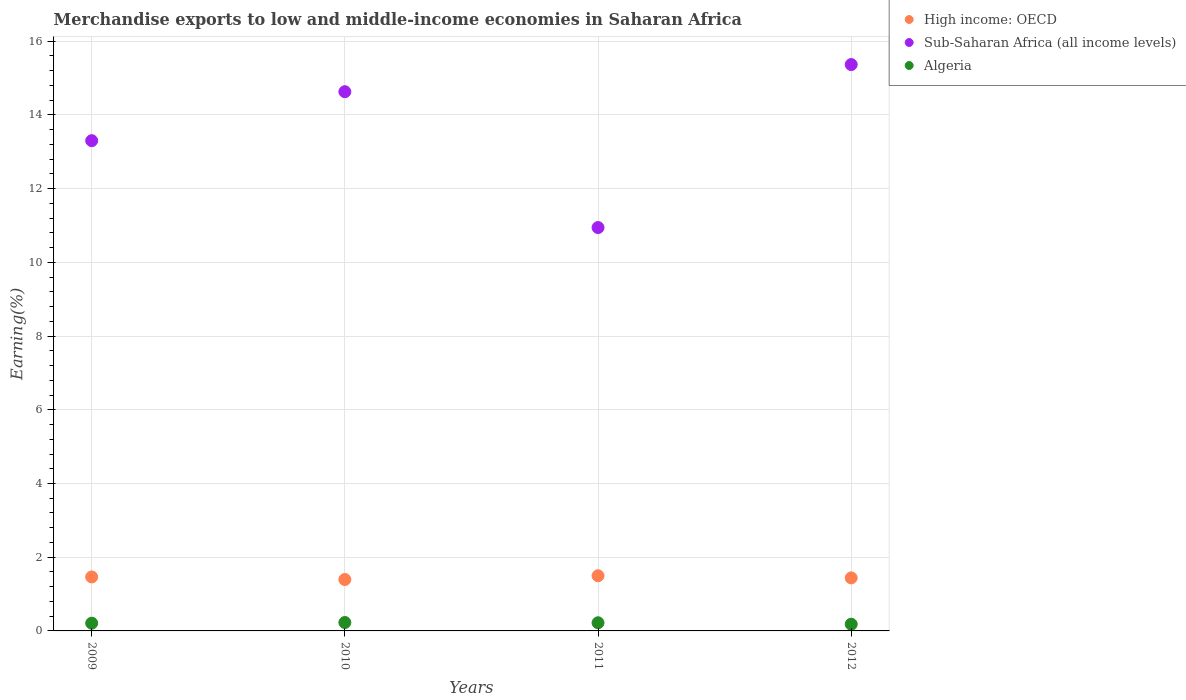Is the number of dotlines equal to the number of legend labels?
Keep it short and to the point. Yes. What is the percentage of amount earned from merchandise exports in Sub-Saharan Africa (all income levels) in 2012?
Provide a succinct answer. 15.37. Across all years, what is the maximum percentage of amount earned from merchandise exports in Algeria?
Provide a short and direct response. 0.23. Across all years, what is the minimum percentage of amount earned from merchandise exports in High income: OECD?
Keep it short and to the point. 1.39. What is the total percentage of amount earned from merchandise exports in Algeria in the graph?
Make the answer very short. 0.84. What is the difference between the percentage of amount earned from merchandise exports in Algeria in 2009 and that in 2012?
Provide a short and direct response. 0.03. What is the difference between the percentage of amount earned from merchandise exports in Algeria in 2010 and the percentage of amount earned from merchandise exports in High income: OECD in 2009?
Keep it short and to the point. -1.24. What is the average percentage of amount earned from merchandise exports in Sub-Saharan Africa (all income levels) per year?
Offer a very short reply. 13.56. In the year 2009, what is the difference between the percentage of amount earned from merchandise exports in Algeria and percentage of amount earned from merchandise exports in High income: OECD?
Your response must be concise. -1.25. In how many years, is the percentage of amount earned from merchandise exports in Algeria greater than 9.2 %?
Your answer should be compact. 0. What is the ratio of the percentage of amount earned from merchandise exports in Sub-Saharan Africa (all income levels) in 2011 to that in 2012?
Ensure brevity in your answer.  0.71. Is the difference between the percentage of amount earned from merchandise exports in Algeria in 2010 and 2011 greater than the difference between the percentage of amount earned from merchandise exports in High income: OECD in 2010 and 2011?
Keep it short and to the point. Yes. What is the difference between the highest and the second highest percentage of amount earned from merchandise exports in Algeria?
Give a very brief answer. 0.01. What is the difference between the highest and the lowest percentage of amount earned from merchandise exports in Sub-Saharan Africa (all income levels)?
Keep it short and to the point. 4.42. Is the sum of the percentage of amount earned from merchandise exports in Algeria in 2010 and 2011 greater than the maximum percentage of amount earned from merchandise exports in High income: OECD across all years?
Provide a short and direct response. No. Does the percentage of amount earned from merchandise exports in Algeria monotonically increase over the years?
Offer a terse response. No. Is the percentage of amount earned from merchandise exports in Sub-Saharan Africa (all income levels) strictly greater than the percentage of amount earned from merchandise exports in High income: OECD over the years?
Give a very brief answer. Yes. Is the percentage of amount earned from merchandise exports in Algeria strictly less than the percentage of amount earned from merchandise exports in Sub-Saharan Africa (all income levels) over the years?
Your answer should be very brief. Yes. How many dotlines are there?
Keep it short and to the point. 3. How many years are there in the graph?
Provide a short and direct response. 4. Does the graph contain any zero values?
Ensure brevity in your answer.  No. Where does the legend appear in the graph?
Your answer should be compact. Top right. How are the legend labels stacked?
Offer a very short reply. Vertical. What is the title of the graph?
Offer a very short reply. Merchandise exports to low and middle-income economies in Saharan Africa. What is the label or title of the Y-axis?
Offer a terse response. Earning(%). What is the Earning(%) of High income: OECD in 2009?
Provide a succinct answer. 1.46. What is the Earning(%) of Sub-Saharan Africa (all income levels) in 2009?
Your answer should be compact. 13.3. What is the Earning(%) in Algeria in 2009?
Offer a terse response. 0.21. What is the Earning(%) in High income: OECD in 2010?
Ensure brevity in your answer.  1.39. What is the Earning(%) in Sub-Saharan Africa (all income levels) in 2010?
Your answer should be very brief. 14.63. What is the Earning(%) of Algeria in 2010?
Provide a succinct answer. 0.23. What is the Earning(%) in High income: OECD in 2011?
Provide a short and direct response. 1.5. What is the Earning(%) in Sub-Saharan Africa (all income levels) in 2011?
Your response must be concise. 10.94. What is the Earning(%) in Algeria in 2011?
Ensure brevity in your answer.  0.22. What is the Earning(%) of High income: OECD in 2012?
Provide a succinct answer. 1.44. What is the Earning(%) in Sub-Saharan Africa (all income levels) in 2012?
Your answer should be compact. 15.37. What is the Earning(%) of Algeria in 2012?
Your answer should be compact. 0.18. Across all years, what is the maximum Earning(%) of High income: OECD?
Your response must be concise. 1.5. Across all years, what is the maximum Earning(%) of Sub-Saharan Africa (all income levels)?
Give a very brief answer. 15.37. Across all years, what is the maximum Earning(%) of Algeria?
Your answer should be very brief. 0.23. Across all years, what is the minimum Earning(%) of High income: OECD?
Provide a short and direct response. 1.39. Across all years, what is the minimum Earning(%) in Sub-Saharan Africa (all income levels)?
Offer a very short reply. 10.94. Across all years, what is the minimum Earning(%) of Algeria?
Your answer should be very brief. 0.18. What is the total Earning(%) in High income: OECD in the graph?
Make the answer very short. 5.8. What is the total Earning(%) of Sub-Saharan Africa (all income levels) in the graph?
Provide a short and direct response. 54.24. What is the total Earning(%) in Algeria in the graph?
Ensure brevity in your answer.  0.84. What is the difference between the Earning(%) of High income: OECD in 2009 and that in 2010?
Ensure brevity in your answer.  0.07. What is the difference between the Earning(%) in Sub-Saharan Africa (all income levels) in 2009 and that in 2010?
Offer a very short reply. -1.33. What is the difference between the Earning(%) in Algeria in 2009 and that in 2010?
Your response must be concise. -0.02. What is the difference between the Earning(%) of High income: OECD in 2009 and that in 2011?
Offer a very short reply. -0.03. What is the difference between the Earning(%) in Sub-Saharan Africa (all income levels) in 2009 and that in 2011?
Provide a short and direct response. 2.36. What is the difference between the Earning(%) of Algeria in 2009 and that in 2011?
Provide a short and direct response. -0.01. What is the difference between the Earning(%) of High income: OECD in 2009 and that in 2012?
Ensure brevity in your answer.  0.03. What is the difference between the Earning(%) in Sub-Saharan Africa (all income levels) in 2009 and that in 2012?
Offer a very short reply. -2.07. What is the difference between the Earning(%) in Algeria in 2009 and that in 2012?
Your answer should be compact. 0.03. What is the difference between the Earning(%) of High income: OECD in 2010 and that in 2011?
Your response must be concise. -0.1. What is the difference between the Earning(%) in Sub-Saharan Africa (all income levels) in 2010 and that in 2011?
Provide a short and direct response. 3.69. What is the difference between the Earning(%) of Algeria in 2010 and that in 2011?
Give a very brief answer. 0.01. What is the difference between the Earning(%) in High income: OECD in 2010 and that in 2012?
Ensure brevity in your answer.  -0.04. What is the difference between the Earning(%) in Sub-Saharan Africa (all income levels) in 2010 and that in 2012?
Provide a succinct answer. -0.74. What is the difference between the Earning(%) in Algeria in 2010 and that in 2012?
Ensure brevity in your answer.  0.05. What is the difference between the Earning(%) of High income: OECD in 2011 and that in 2012?
Provide a short and direct response. 0.06. What is the difference between the Earning(%) of Sub-Saharan Africa (all income levels) in 2011 and that in 2012?
Offer a very short reply. -4.42. What is the difference between the Earning(%) of Algeria in 2011 and that in 2012?
Give a very brief answer. 0.04. What is the difference between the Earning(%) of High income: OECD in 2009 and the Earning(%) of Sub-Saharan Africa (all income levels) in 2010?
Ensure brevity in your answer.  -13.16. What is the difference between the Earning(%) in High income: OECD in 2009 and the Earning(%) in Algeria in 2010?
Keep it short and to the point. 1.24. What is the difference between the Earning(%) in Sub-Saharan Africa (all income levels) in 2009 and the Earning(%) in Algeria in 2010?
Provide a succinct answer. 13.07. What is the difference between the Earning(%) in High income: OECD in 2009 and the Earning(%) in Sub-Saharan Africa (all income levels) in 2011?
Your answer should be compact. -9.48. What is the difference between the Earning(%) of High income: OECD in 2009 and the Earning(%) of Algeria in 2011?
Make the answer very short. 1.24. What is the difference between the Earning(%) of Sub-Saharan Africa (all income levels) in 2009 and the Earning(%) of Algeria in 2011?
Your response must be concise. 13.08. What is the difference between the Earning(%) in High income: OECD in 2009 and the Earning(%) in Sub-Saharan Africa (all income levels) in 2012?
Make the answer very short. -13.9. What is the difference between the Earning(%) in High income: OECD in 2009 and the Earning(%) in Algeria in 2012?
Your answer should be compact. 1.28. What is the difference between the Earning(%) of Sub-Saharan Africa (all income levels) in 2009 and the Earning(%) of Algeria in 2012?
Give a very brief answer. 13.12. What is the difference between the Earning(%) of High income: OECD in 2010 and the Earning(%) of Sub-Saharan Africa (all income levels) in 2011?
Give a very brief answer. -9.55. What is the difference between the Earning(%) in High income: OECD in 2010 and the Earning(%) in Algeria in 2011?
Offer a very short reply. 1.17. What is the difference between the Earning(%) of Sub-Saharan Africa (all income levels) in 2010 and the Earning(%) of Algeria in 2011?
Offer a very short reply. 14.41. What is the difference between the Earning(%) of High income: OECD in 2010 and the Earning(%) of Sub-Saharan Africa (all income levels) in 2012?
Your response must be concise. -13.97. What is the difference between the Earning(%) of High income: OECD in 2010 and the Earning(%) of Algeria in 2012?
Offer a terse response. 1.21. What is the difference between the Earning(%) in Sub-Saharan Africa (all income levels) in 2010 and the Earning(%) in Algeria in 2012?
Ensure brevity in your answer.  14.45. What is the difference between the Earning(%) of High income: OECD in 2011 and the Earning(%) of Sub-Saharan Africa (all income levels) in 2012?
Ensure brevity in your answer.  -13.87. What is the difference between the Earning(%) in High income: OECD in 2011 and the Earning(%) in Algeria in 2012?
Your answer should be very brief. 1.31. What is the difference between the Earning(%) in Sub-Saharan Africa (all income levels) in 2011 and the Earning(%) in Algeria in 2012?
Your response must be concise. 10.76. What is the average Earning(%) in High income: OECD per year?
Offer a very short reply. 1.45. What is the average Earning(%) of Sub-Saharan Africa (all income levels) per year?
Provide a succinct answer. 13.56. What is the average Earning(%) of Algeria per year?
Your answer should be very brief. 0.21. In the year 2009, what is the difference between the Earning(%) of High income: OECD and Earning(%) of Sub-Saharan Africa (all income levels)?
Make the answer very short. -11.84. In the year 2009, what is the difference between the Earning(%) of High income: OECD and Earning(%) of Algeria?
Give a very brief answer. 1.25. In the year 2009, what is the difference between the Earning(%) in Sub-Saharan Africa (all income levels) and Earning(%) in Algeria?
Give a very brief answer. 13.09. In the year 2010, what is the difference between the Earning(%) of High income: OECD and Earning(%) of Sub-Saharan Africa (all income levels)?
Your answer should be very brief. -13.23. In the year 2010, what is the difference between the Earning(%) of High income: OECD and Earning(%) of Algeria?
Your answer should be very brief. 1.17. In the year 2010, what is the difference between the Earning(%) in Sub-Saharan Africa (all income levels) and Earning(%) in Algeria?
Your answer should be compact. 14.4. In the year 2011, what is the difference between the Earning(%) of High income: OECD and Earning(%) of Sub-Saharan Africa (all income levels)?
Make the answer very short. -9.45. In the year 2011, what is the difference between the Earning(%) in High income: OECD and Earning(%) in Algeria?
Your answer should be very brief. 1.28. In the year 2011, what is the difference between the Earning(%) of Sub-Saharan Africa (all income levels) and Earning(%) of Algeria?
Provide a short and direct response. 10.72. In the year 2012, what is the difference between the Earning(%) in High income: OECD and Earning(%) in Sub-Saharan Africa (all income levels)?
Offer a very short reply. -13.93. In the year 2012, what is the difference between the Earning(%) in High income: OECD and Earning(%) in Algeria?
Your answer should be compact. 1.26. In the year 2012, what is the difference between the Earning(%) in Sub-Saharan Africa (all income levels) and Earning(%) in Algeria?
Provide a succinct answer. 15.18. What is the ratio of the Earning(%) of High income: OECD in 2009 to that in 2010?
Make the answer very short. 1.05. What is the ratio of the Earning(%) in Sub-Saharan Africa (all income levels) in 2009 to that in 2010?
Offer a terse response. 0.91. What is the ratio of the Earning(%) of Algeria in 2009 to that in 2010?
Keep it short and to the point. 0.92. What is the ratio of the Earning(%) in High income: OECD in 2009 to that in 2011?
Your answer should be compact. 0.98. What is the ratio of the Earning(%) in Sub-Saharan Africa (all income levels) in 2009 to that in 2011?
Provide a succinct answer. 1.22. What is the ratio of the Earning(%) in Algeria in 2009 to that in 2011?
Give a very brief answer. 0.95. What is the ratio of the Earning(%) of High income: OECD in 2009 to that in 2012?
Offer a terse response. 1.02. What is the ratio of the Earning(%) of Sub-Saharan Africa (all income levels) in 2009 to that in 2012?
Make the answer very short. 0.87. What is the ratio of the Earning(%) of Algeria in 2009 to that in 2012?
Keep it short and to the point. 1.15. What is the ratio of the Earning(%) of High income: OECD in 2010 to that in 2011?
Provide a short and direct response. 0.93. What is the ratio of the Earning(%) of Sub-Saharan Africa (all income levels) in 2010 to that in 2011?
Provide a succinct answer. 1.34. What is the ratio of the Earning(%) in Algeria in 2010 to that in 2011?
Make the answer very short. 1.03. What is the ratio of the Earning(%) of High income: OECD in 2010 to that in 2012?
Offer a terse response. 0.97. What is the ratio of the Earning(%) in Sub-Saharan Africa (all income levels) in 2010 to that in 2012?
Your answer should be compact. 0.95. What is the ratio of the Earning(%) of Algeria in 2010 to that in 2012?
Your answer should be very brief. 1.26. What is the ratio of the Earning(%) of High income: OECD in 2011 to that in 2012?
Your response must be concise. 1.04. What is the ratio of the Earning(%) of Sub-Saharan Africa (all income levels) in 2011 to that in 2012?
Provide a short and direct response. 0.71. What is the ratio of the Earning(%) of Algeria in 2011 to that in 2012?
Offer a terse response. 1.22. What is the difference between the highest and the second highest Earning(%) of High income: OECD?
Offer a very short reply. 0.03. What is the difference between the highest and the second highest Earning(%) in Sub-Saharan Africa (all income levels)?
Your response must be concise. 0.74. What is the difference between the highest and the second highest Earning(%) in Algeria?
Offer a terse response. 0.01. What is the difference between the highest and the lowest Earning(%) of High income: OECD?
Keep it short and to the point. 0.1. What is the difference between the highest and the lowest Earning(%) of Sub-Saharan Africa (all income levels)?
Your response must be concise. 4.42. What is the difference between the highest and the lowest Earning(%) of Algeria?
Ensure brevity in your answer.  0.05. 